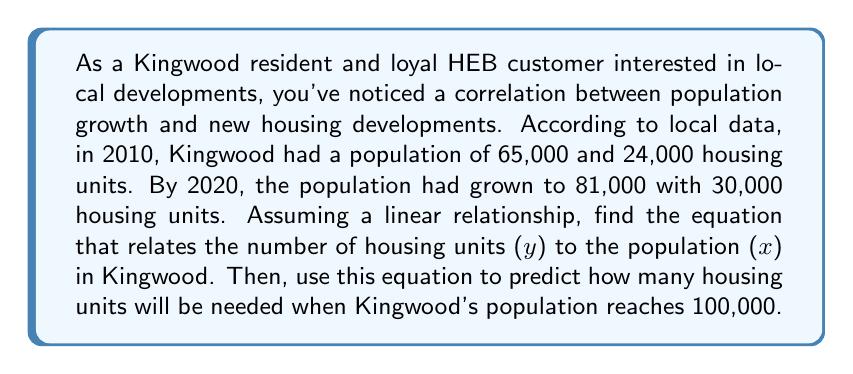Help me with this question. Let's approach this step-by-step:

1) We're looking for a linear equation in the form $y = mx + b$, where:
   $y$ = number of housing units
   $x$ = population
   $m$ = slope (rate of change)
   $b$ = y-intercept

2) We have two points:
   (65,000, 24,000) for 2010
   (81,000, 30,000) for 2020

3) Let's calculate the slope (m):
   $$m = \frac{y_2 - y_1}{x_2 - x_1} = \frac{30,000 - 24,000}{81,000 - 65,000} = \frac{6,000}{16,000} = 0.375$$

4) Now we can use either point to find b. Let's use (65,000, 24,000):
   $$24,000 = 0.375(65,000) + b$$
   $$24,000 = 24,375 + b$$
   $$b = 24,000 - 24,375 = -375$$

5) Our linear equation is:
   $$y = 0.375x - 375$$

6) To predict housing units for a population of 100,000:
   $$y = 0.375(100,000) - 375 = 37,500 - 375 = 37,125$$
Answer: The linear equation relating housing units (y) to population (x) in Kingwood is $y = 0.375x - 375$. When the population reaches 100,000, Kingwood will need approximately 37,125 housing units. 